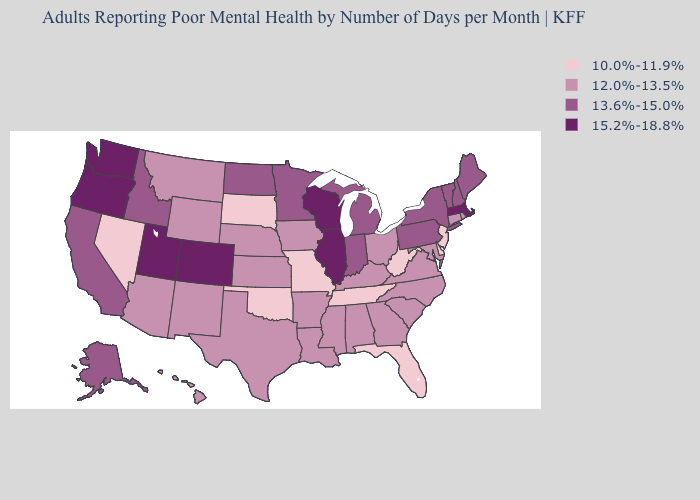What is the lowest value in the Northeast?
Be succinct. 10.0%-11.9%. What is the value of Delaware?
Write a very short answer. 10.0%-11.9%. Among the states that border Virginia , does North Carolina have the lowest value?
Give a very brief answer. No. Among the states that border Missouri , which have the lowest value?
Give a very brief answer. Oklahoma, Tennessee. What is the highest value in the USA?
Give a very brief answer. 15.2%-18.8%. Does Kansas have the highest value in the USA?
Quick response, please. No. Among the states that border Texas , which have the lowest value?
Be succinct. Oklahoma. Among the states that border North Dakota , which have the highest value?
Quick response, please. Minnesota. Does Idaho have a higher value than Arizona?
Give a very brief answer. Yes. How many symbols are there in the legend?
Answer briefly. 4. Name the states that have a value in the range 15.2%-18.8%?
Answer briefly. Colorado, Illinois, Massachusetts, Oregon, Utah, Washington, Wisconsin. Among the states that border Delaware , which have the highest value?
Answer briefly. Pennsylvania. What is the value of New Hampshire?
Concise answer only. 13.6%-15.0%. Among the states that border Wyoming , does Colorado have the lowest value?
Short answer required. No. 